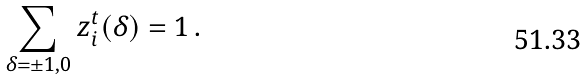<formula> <loc_0><loc_0><loc_500><loc_500>\sum _ { \delta = \pm 1 , 0 } z _ { i } ^ { t } ( \delta ) = 1 \, .</formula> 